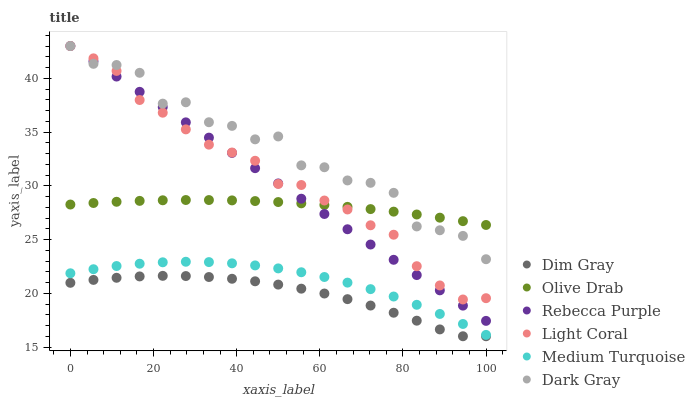Does Dim Gray have the minimum area under the curve?
Answer yes or no. Yes. Does Dark Gray have the maximum area under the curve?
Answer yes or no. Yes. Does Light Coral have the minimum area under the curve?
Answer yes or no. No. Does Light Coral have the maximum area under the curve?
Answer yes or no. No. Is Rebecca Purple the smoothest?
Answer yes or no. Yes. Is Dark Gray the roughest?
Answer yes or no. Yes. Is Dim Gray the smoothest?
Answer yes or no. No. Is Dim Gray the roughest?
Answer yes or no. No. Does Dim Gray have the lowest value?
Answer yes or no. Yes. Does Light Coral have the lowest value?
Answer yes or no. No. Does Rebecca Purple have the highest value?
Answer yes or no. Yes. Does Dim Gray have the highest value?
Answer yes or no. No. Is Dim Gray less than Medium Turquoise?
Answer yes or no. Yes. Is Rebecca Purple greater than Medium Turquoise?
Answer yes or no. Yes. Does Olive Drab intersect Light Coral?
Answer yes or no. Yes. Is Olive Drab less than Light Coral?
Answer yes or no. No. Is Olive Drab greater than Light Coral?
Answer yes or no. No. Does Dim Gray intersect Medium Turquoise?
Answer yes or no. No. 